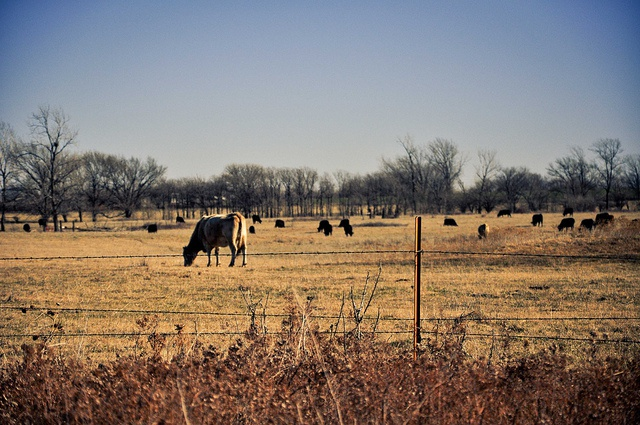Describe the objects in this image and their specific colors. I can see cow in blue, black, tan, and khaki tones, cow in blue, black, gray, and tan tones, cow in blue, black, and gray tones, cow in blue, black, maroon, and gray tones, and cow in blue, black, gray, and tan tones in this image. 